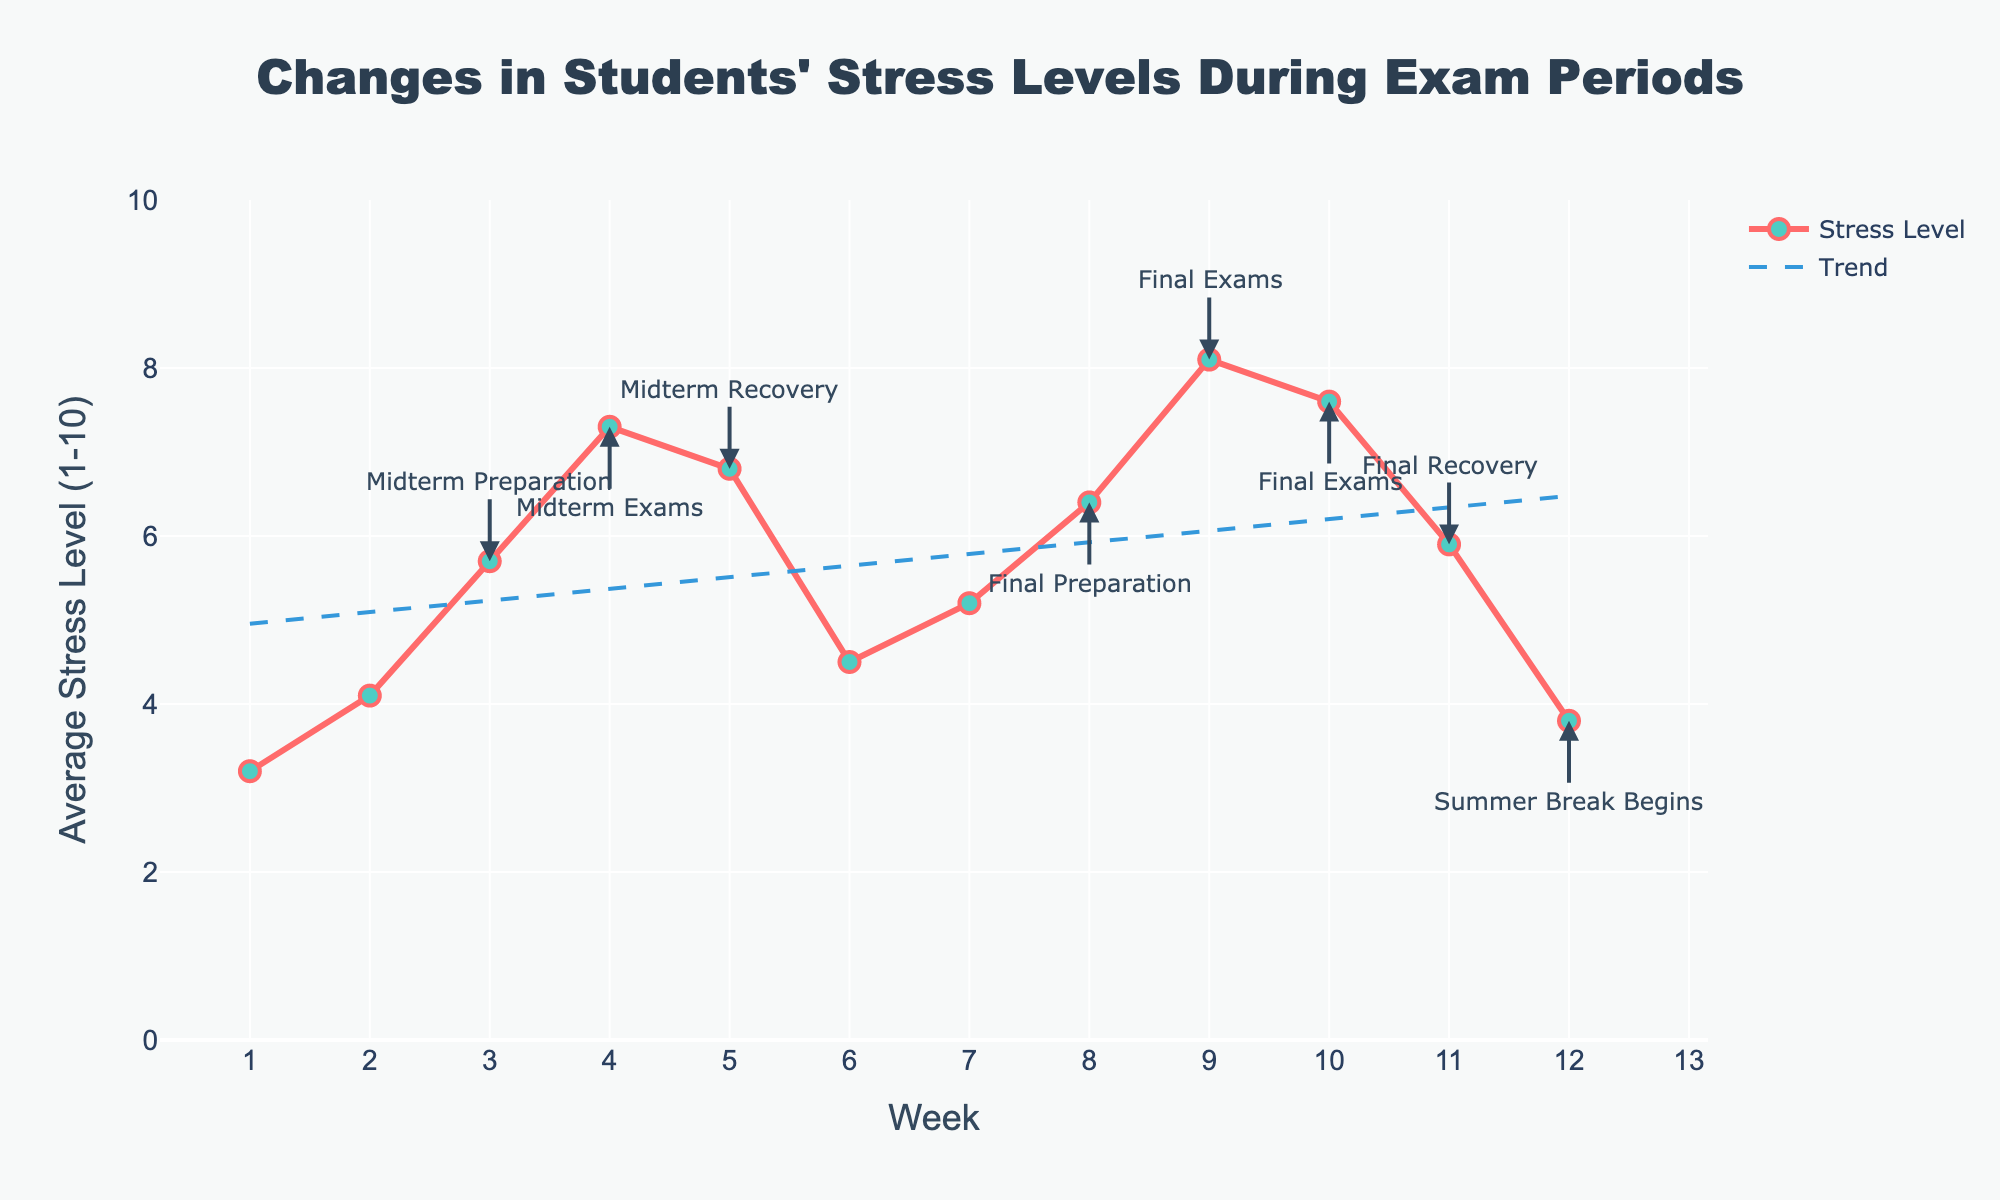What is the average stress level during the midterm exams? The midterm exams occur on week 4. Refer to the plot to find the stress level at week 4, which is 7.3.
Answer: 7.3 Which exam period shows the highest average stress level? Look at the plot and identify the exam period with the highest peak. The highest peak is during the final exams in week 9 with a stress level of 8.1.
Answer: Final Exams (week 9) What is the difference in stress levels between midterm preparation and midterm recovery weeks? Find the stress level for the midterm preparation (week 3) and the midterm recovery (week 5). Subtract the week 5 stress level (6.8) from the week 3 stress level (5.7): 7.3 - 6.8 = 0.5.
Answer: 0.5 How does the stress level trend during exam periods compared to regular coursework weeks? During exam periods, especially around midterm and final exams, the stress level peaks significantly compared to regular coursework weeks, which are relatively stable and low. For example, the stress level rises from a regular coursework level of 3.2 in week 1 to a peak of 8.1 in week 9 during final exams.
Answer: Exam periods show higher stress levels than regular coursework weeks Compare the stress level at the beginning of the semester with the start of summer break. At the beginning of the semester (week 1), the stress level is 3.2, while it is 3.8 in week 12, the start of summer break, indicating a slight increase.
Answer: Stress level slightly increases Which week shows the lowest average stress level? From the plot, the weeks with the lowest stress levels are week 1 (3.2) and week 12 (3.8). Week 1 has the lowest average stress level of 3.2.
Answer: Week 1 Is there a significant drop in the stress level following the final exams? Final exams end in week 10, with a stress level of 7.6. In week 11, the stress level drops to 5.9, showing a significant decrease of 1.7 points.
Answer: Yes What is the trend of the stress level from week 1 to week 12? The overall trend shows an increase in stress levels towards the midterm and final exam periods, followed by a decline after each exam period, and a final drop at the beginning of summer break.
Answer: Increasing then decreasing What is the median stress level during the 12 weeks? List the stress levels: 3.2, 4.1, 5.7, 7.3, 6.8, 4.5, 5.2, 6.4, 8.1, 7.6, 5.9, 3.8. The middle values are 5.7 and 6.4. Median is (5.7 + 6.4)/2 = 6.05.
Answer: 6.05 